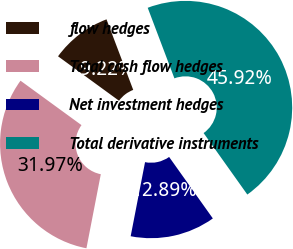<chart> <loc_0><loc_0><loc_500><loc_500><pie_chart><fcel>flow hedges<fcel>Total cash flow hedges<fcel>Net investment hedges<fcel>Total derivative instruments<nl><fcel>9.22%<fcel>31.97%<fcel>12.89%<fcel>45.92%<nl></chart> 